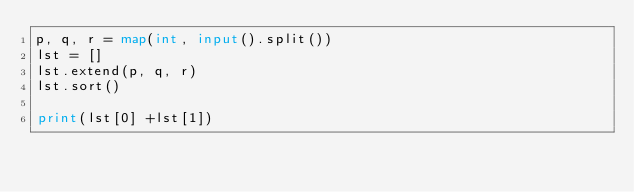<code> <loc_0><loc_0><loc_500><loc_500><_Python_>p, q, r = map(int, input().split())
lst = []
lst.extend(p, q, r)
lst.sort()

print(lst[0] +lst[1])</code> 